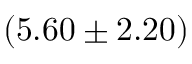<formula> <loc_0><loc_0><loc_500><loc_500>( 5 . 6 0 \pm 2 . 2 0 ) \</formula> 